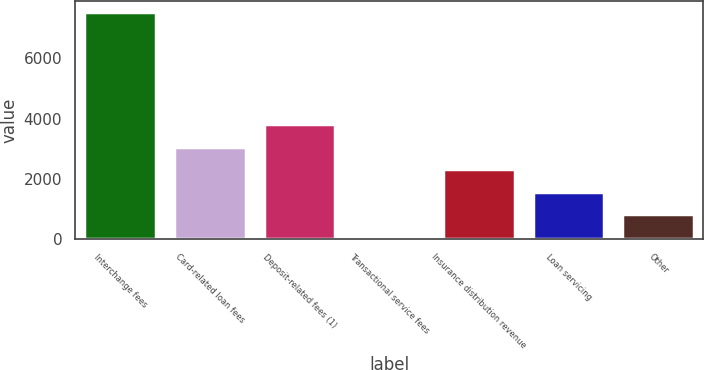Convert chart. <chart><loc_0><loc_0><loc_500><loc_500><bar_chart><fcel>Interchange fees<fcel>Card-related loan fees<fcel>Deposit-related fees (1)<fcel>Transactional service fees<fcel>Insurance distribution revenue<fcel>Loan servicing<fcel>Other<nl><fcel>7526<fcel>3065<fcel>3808.5<fcel>91<fcel>2321.5<fcel>1578<fcel>834.5<nl></chart> 